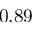<formula> <loc_0><loc_0><loc_500><loc_500>0 . 8 9</formula> 